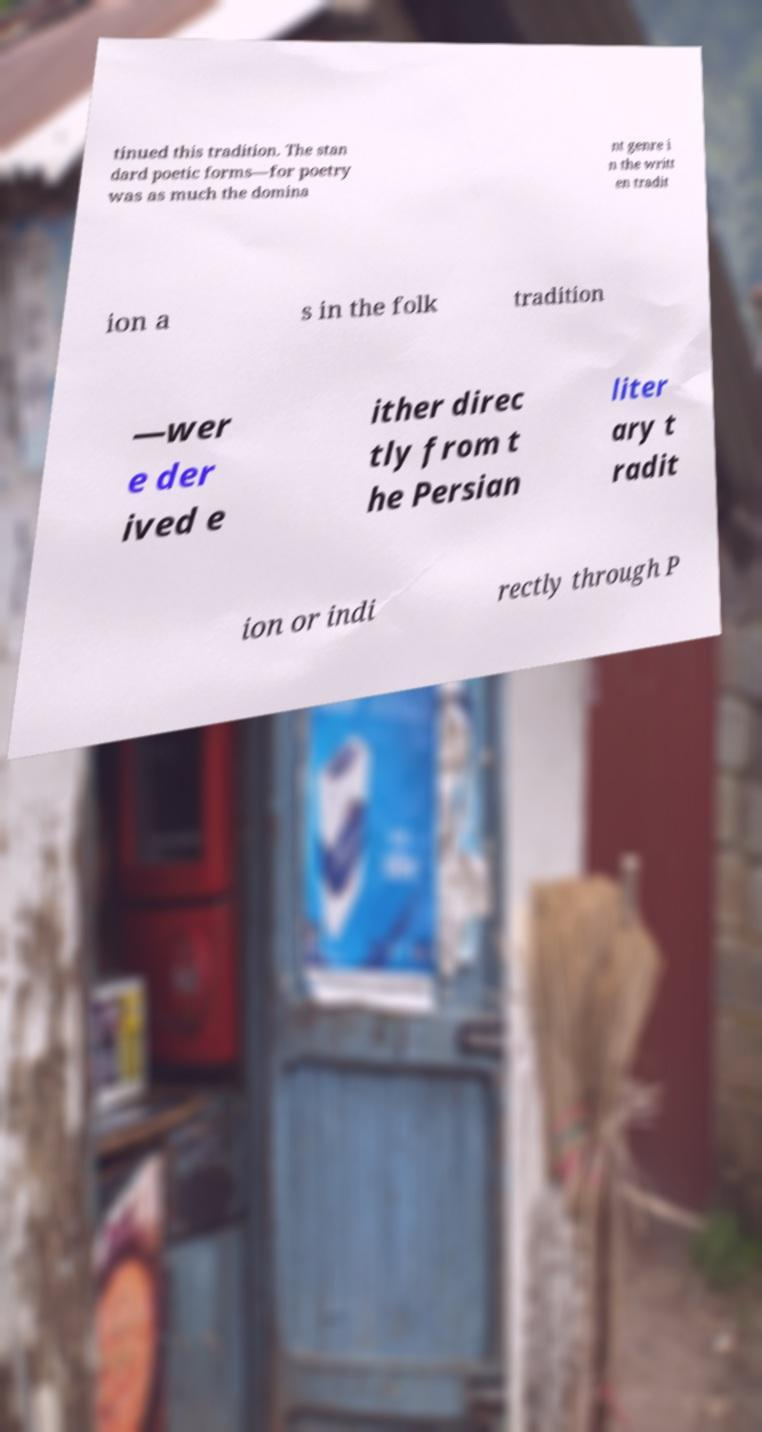Could you extract and type out the text from this image? tinued this tradition. The stan dard poetic forms—for poetry was as much the domina nt genre i n the writt en tradit ion a s in the folk tradition —wer e der ived e ither direc tly from t he Persian liter ary t radit ion or indi rectly through P 